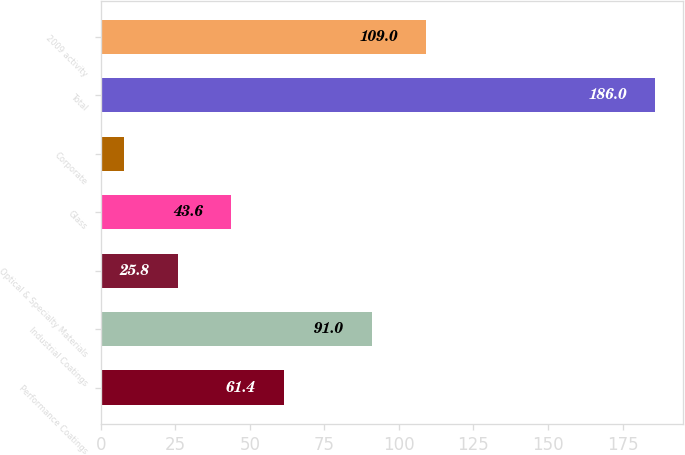Convert chart to OTSL. <chart><loc_0><loc_0><loc_500><loc_500><bar_chart><fcel>Performance Coatings<fcel>Industrial Coatings<fcel>Optical & Specialty Materials<fcel>Glass<fcel>Corporate<fcel>Total<fcel>2009 activity<nl><fcel>61.4<fcel>91<fcel>25.8<fcel>43.6<fcel>8<fcel>186<fcel>109<nl></chart> 